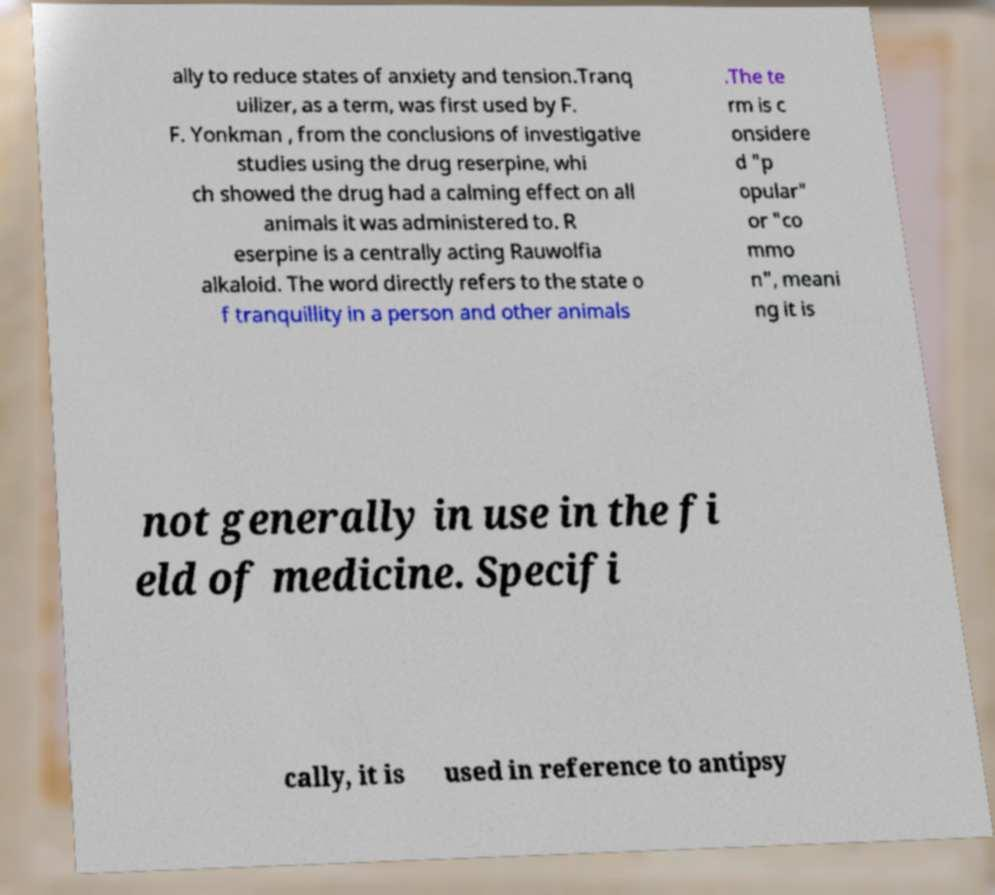Could you assist in decoding the text presented in this image and type it out clearly? ally to reduce states of anxiety and tension.Tranq uilizer, as a term, was first used by F. F. Yonkman , from the conclusions of investigative studies using the drug reserpine, whi ch showed the drug had a calming effect on all animals it was administered to. R eserpine is a centrally acting Rauwolfia alkaloid. The word directly refers to the state o f tranquillity in a person and other animals .The te rm is c onsidere d "p opular" or "co mmo n", meani ng it is not generally in use in the fi eld of medicine. Specifi cally, it is used in reference to antipsy 